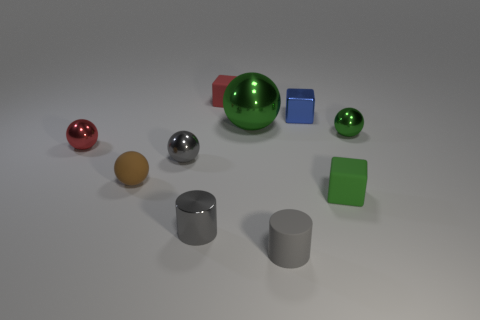Subtract 2 spheres. How many spheres are left? 3 Subtract all gray balls. How many balls are left? 4 Subtract all small red spheres. How many spheres are left? 4 Subtract all purple spheres. Subtract all yellow blocks. How many spheres are left? 5 Subtract all blocks. How many objects are left? 7 Add 7 purple rubber blocks. How many purple rubber blocks exist? 7 Subtract 0 brown cylinders. How many objects are left? 10 Subtract all large spheres. Subtract all metal blocks. How many objects are left? 8 Add 7 green spheres. How many green spheres are left? 9 